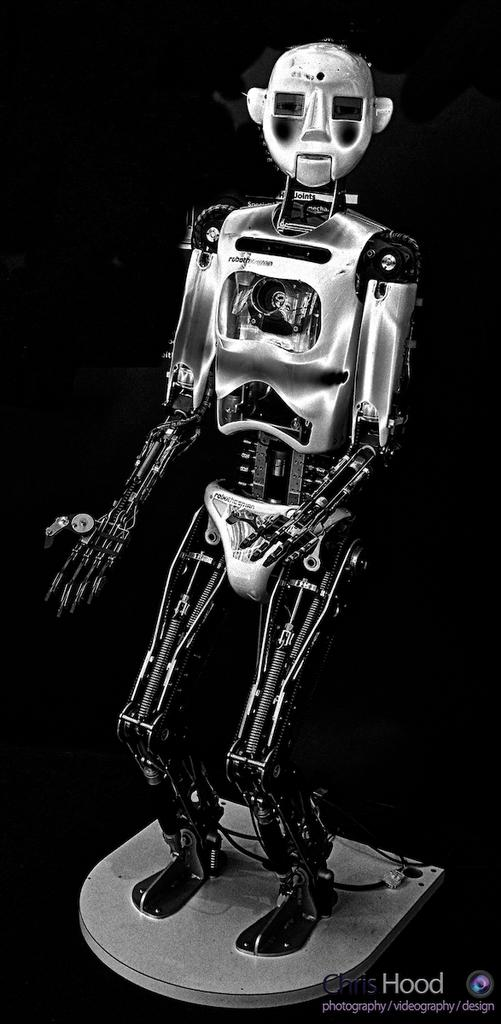What is the main subject of the image? There is a robot in the image. Is there any text present in the image? Yes, there is text on the bottom right side of the image. What can be observed about the background of the image? The background of the image is completely dark. How many cubs can be seen playing with the robot in the image? There are no cubs present in the image; it features a robot and text on a dark background. What type of houses are visible in the background of the image? There are no houses visible in the image; the background is completely dark. 